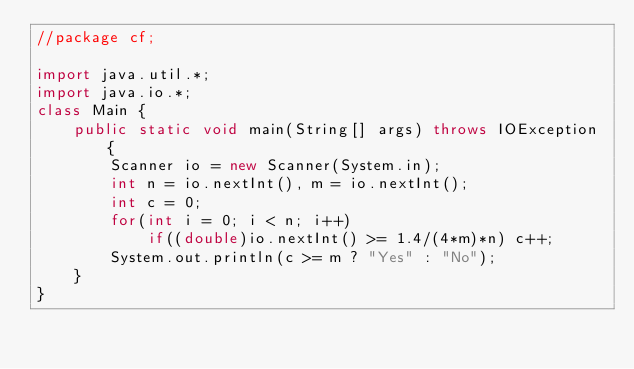<code> <loc_0><loc_0><loc_500><loc_500><_Java_>//package cf;

import java.util.*;
import java.io.*;
class Main {
    public static void main(String[] args) throws IOException {
        Scanner io = new Scanner(System.in);
        int n = io.nextInt(), m = io.nextInt();
        int c = 0;
        for(int i = 0; i < n; i++)
            if((double)io.nextInt() >= 1.4/(4*m)*n) c++;
        System.out.println(c >= m ? "Yes" : "No");
    }
}


</code> 